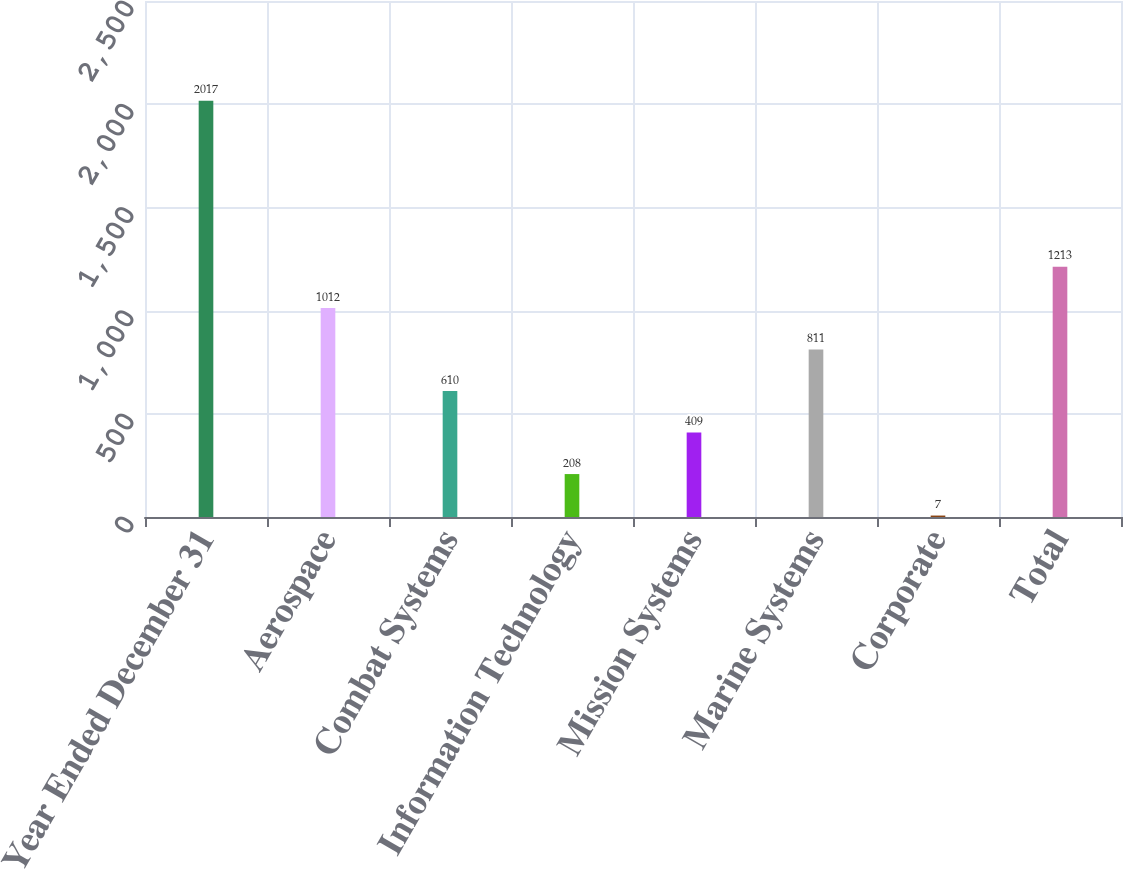Convert chart to OTSL. <chart><loc_0><loc_0><loc_500><loc_500><bar_chart><fcel>Year Ended December 31<fcel>Aerospace<fcel>Combat Systems<fcel>Information Technology<fcel>Mission Systems<fcel>Marine Systems<fcel>Corporate<fcel>Total<nl><fcel>2017<fcel>1012<fcel>610<fcel>208<fcel>409<fcel>811<fcel>7<fcel>1213<nl></chart> 